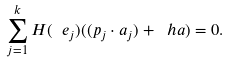<formula> <loc_0><loc_0><loc_500><loc_500>\sum _ { j = 1 } ^ { k } H ( \ e _ { j } ) ( ( p _ { j } \cdot a _ { j } ) + \ h a ) = 0 .</formula> 